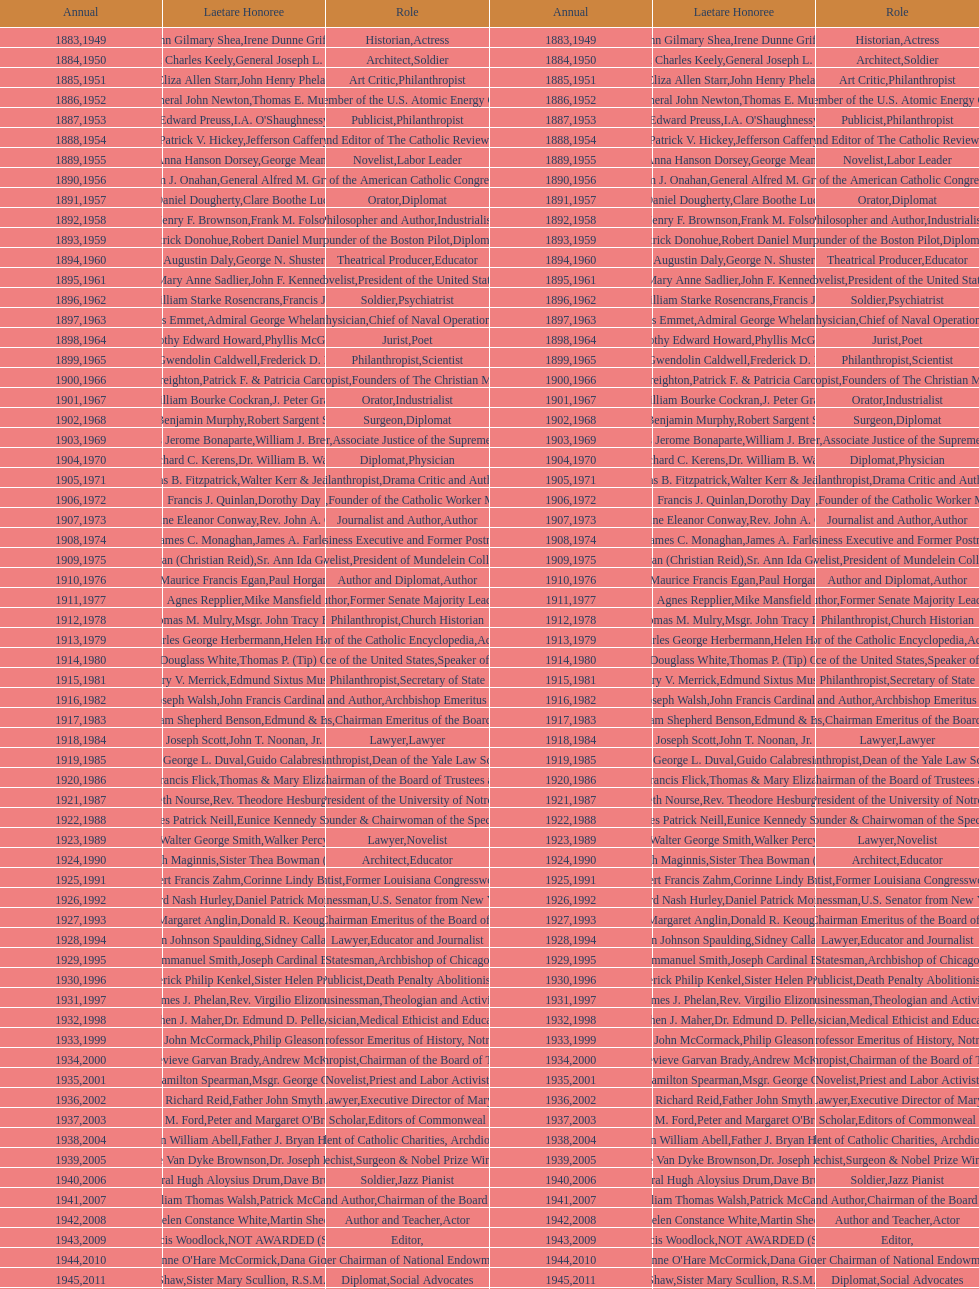How many are or were journalists? 5. Could you parse the entire table as a dict? {'header': ['Annual', 'Laetare Honoree', 'Role', 'Annual', 'Laetare Honoree', 'Role'], 'rows': [['1883', 'John Gilmary Shea', 'Historian', '1949', 'Irene Dunne Griffin', 'Actress'], ['1884', 'Patrick Charles Keely', 'Architect', '1950', 'General Joseph L. Collins', 'Soldier'], ['1885', 'Eliza Allen Starr', 'Art Critic', '1951', 'John Henry Phelan', 'Philanthropist'], ['1886', 'General John Newton', 'Engineer', '1952', 'Thomas E. Murray', 'Member of the U.S. Atomic Energy Commission'], ['1887', 'Edward Preuss', 'Publicist', '1953', "I.A. O'Shaughnessy", 'Philanthropist'], ['1888', 'Patrick V. Hickey', 'Founder and Editor of The Catholic Review', '1954', 'Jefferson Caffery', 'Diplomat'], ['1889', 'Anna Hanson Dorsey', 'Novelist', '1955', 'George Meany', 'Labor Leader'], ['1890', 'William J. Onahan', 'Organizer of the American Catholic Congress', '1956', 'General Alfred M. Gruenther', 'Soldier'], ['1891', 'Daniel Dougherty', 'Orator', '1957', 'Clare Boothe Luce', 'Diplomat'], ['1892', 'Henry F. Brownson', 'Philosopher and Author', '1958', 'Frank M. Folsom', 'Industrialist'], ['1893', 'Patrick Donohue', 'Founder of the Boston Pilot', '1959', 'Robert Daniel Murphy', 'Diplomat'], ['1894', 'Augustin Daly', 'Theatrical Producer', '1960', 'George N. Shuster', 'Educator'], ['1895', 'Mary Anne Sadlier', 'Novelist', '1961', 'John F. Kennedy', 'President of the United States'], ['1896', 'General William Starke Rosencrans', 'Soldier', '1962', 'Francis J. Braceland', 'Psychiatrist'], ['1897', 'Thomas Addis Emmet', 'Physician', '1963', 'Admiral George Whelan Anderson, Jr.', 'Chief of Naval Operations'], ['1898', 'Timothy Edward Howard', 'Jurist', '1964', 'Phyllis McGinley', 'Poet'], ['1899', 'Mary Gwendolin Caldwell', 'Philanthropist', '1965', 'Frederick D. Rossini', 'Scientist'], ['1900', 'John A. Creighton', 'Philanthropist', '1966', 'Patrick F. & Patricia Caron Crowley', 'Founders of The Christian Movement'], ['1901', 'William Bourke Cockran', 'Orator', '1967', 'J. Peter Grace', 'Industrialist'], ['1902', 'John Benjamin Murphy', 'Surgeon', '1968', 'Robert Sargent Shriver', 'Diplomat'], ['1903', 'Charles Jerome Bonaparte', 'Lawyer', '1969', 'William J. Brennan Jr.', 'Associate Justice of the Supreme Court'], ['1904', 'Richard C. Kerens', 'Diplomat', '1970', 'Dr. William B. Walsh', 'Physician'], ['1905', 'Thomas B. Fitzpatrick', 'Philanthropist', '1971', 'Walter Kerr & Jean Kerr', 'Drama Critic and Author'], ['1906', 'Francis J. Quinlan', 'Physician', '1972', 'Dorothy Day', 'Founder of the Catholic Worker Movement'], ['1907', 'Katherine Eleanor Conway', 'Journalist and Author', '1973', "Rev. John A. O'Brien", 'Author'], ['1908', 'James C. Monaghan', 'Economist', '1974', 'James A. Farley', 'Business Executive and Former Postmaster General'], ['1909', 'Frances Tieran (Christian Reid)', 'Novelist', '1975', 'Sr. Ann Ida Gannon, BMV', 'President of Mundelein College'], ['1910', 'Maurice Francis Egan', 'Author and Diplomat', '1976', 'Paul Horgan', 'Author'], ['1911', 'Agnes Repplier', 'Author', '1977', 'Mike Mansfield', 'Former Senate Majority Leader'], ['1912', 'Thomas M. Mulry', 'Philanthropist', '1978', 'Msgr. John Tracy Ellis', 'Church Historian'], ['1913', 'Charles George Herbermann', 'Editor of the Catholic Encyclopedia', '1979', 'Helen Hayes', 'Actress'], ['1914', 'Edward Douglass White', 'Chief Justice of the United States', '1980', "Thomas P. (Tip) O'Neill Jr.", 'Speaker of the House'], ['1915', 'Mary V. Merrick', 'Philanthropist', '1981', 'Edmund Sixtus Muskie', 'Secretary of State'], ['1916', 'James Joseph Walsh', 'Physician and Author', '1982', 'John Francis Cardinal Dearden', 'Archbishop Emeritus of Detroit'], ['1917', 'Admiral William Shepherd Benson', 'Chief of Naval Operations', '1983', 'Edmund & Evelyn Stephan', 'Chairman Emeritus of the Board of Trustees and his wife'], ['1918', 'Joseph Scott', 'Lawyer', '1984', 'John T. Noonan, Jr.', 'Lawyer'], ['1919', 'George L. Duval', 'Philanthropist', '1985', 'Guido Calabresi', 'Dean of the Yale Law School'], ['1920', 'Lawrence Francis Flick', 'Physician', '1986', 'Thomas & Mary Elizabeth Carney', 'Chairman of the Board of Trustees and his wife'], ['1921', 'Elizabeth Nourse', 'Artist', '1987', 'Rev. Theodore Hesburgh, CSC', 'President of the University of Notre Dame'], ['1922', 'Charles Patrick Neill', 'Economist', '1988', 'Eunice Kennedy Shriver', 'Founder & Chairwoman of the Special Olympics'], ['1923', 'Walter George Smith', 'Lawyer', '1989', 'Walker Percy', 'Novelist'], ['1924', 'Charles Donagh Maginnis', 'Architect', '1990', 'Sister Thea Bowman (posthumously)', 'Educator'], ['1925', 'Albert Francis Zahm', 'Scientist', '1991', 'Corinne Lindy Boggs', 'Former Louisiana Congresswoman'], ['1926', 'Edward Nash Hurley', 'Businessman', '1992', 'Daniel Patrick Moynihan', 'U.S. Senator from New York'], ['1927', 'Margaret Anglin', 'Actress', '1993', 'Donald R. Keough', 'Chairman Emeritus of the Board of Trustees'], ['1928', 'John Johnson Spaulding', 'Lawyer', '1994', 'Sidney Callahan', 'Educator and Journalist'], ['1929', 'Alfred Emmanuel Smith', 'Statesman', '1995', 'Joseph Cardinal Bernardin', 'Archbishop of Chicago'], ['1930', 'Frederick Philip Kenkel', 'Publicist', '1996', 'Sister Helen Prejean', 'Death Penalty Abolitionist'], ['1931', 'James J. Phelan', 'Businessman', '1997', 'Rev. Virgilio Elizondo', 'Theologian and Activist'], ['1932', 'Stephen J. Maher', 'Physician', '1998', 'Dr. Edmund D. Pellegrino', 'Medical Ethicist and Educator'], ['1933', 'John McCormack', 'Artist', '1999', 'Philip Gleason', 'Professor Emeritus of History, Notre Dame'], ['1934', 'Genevieve Garvan Brady', 'Philanthropist', '2000', 'Andrew McKenna', 'Chairman of the Board of Trustees'], ['1935', 'Francis Hamilton Spearman', 'Novelist', '2001', 'Msgr. George G. Higgins', 'Priest and Labor Activist'], ['1936', 'Richard Reid', 'Journalist and Lawyer', '2002', 'Father John Smyth', 'Executive Director of Maryville Academy'], ['1937', 'Jeremiah D. M. Ford', 'Scholar', '2003', "Peter and Margaret O'Brien Steinfels", 'Editors of Commonweal'], ['1938', 'Irvin William Abell', 'Surgeon', '2004', 'Father J. Bryan Hehir', 'President of Catholic Charities, Archdiocese of Boston'], ['1939', 'Josephine Van Dyke Brownson', 'Catechist', '2005', 'Dr. Joseph E. Murray', 'Surgeon & Nobel Prize Winner'], ['1940', 'General Hugh Aloysius Drum', 'Soldier', '2006', 'Dave Brubeck', 'Jazz Pianist'], ['1941', 'William Thomas Walsh', 'Journalist and Author', '2007', 'Patrick McCartan', 'Chairman of the Board of Trustees'], ['1942', 'Helen Constance White', 'Author and Teacher', '2008', 'Martin Sheen', 'Actor'], ['1943', 'Thomas Francis Woodlock', 'Editor', '2009', 'NOT AWARDED (SEE BELOW)', ''], ['1944', "Anne O'Hare McCormick", 'Journalist', '2010', 'Dana Gioia', 'Former Chairman of National Endowment for the Arts'], ['1945', 'Gardiner Howland Shaw', 'Diplomat', '2011', 'Sister Mary Scullion, R.S.M., & Joan McConnon', 'Social Advocates'], ['1946', 'Carlton J. H. Hayes', 'Historian and Diplomat', '2012', 'Ken Hackett', 'Former President of Catholic Relief Services'], ['1947', 'William G. Bruce', 'Publisher and Civic Leader', '2013', 'Sister Susanne Gallagher, S.P.\\nSister Mary Therese Harrington, S.H.\\nRev. James H. McCarthy', 'Founders of S.P.R.E.D. (Special Religious Education Development Network)'], ['1948', 'Frank C. Walker', 'Postmaster General and Civic Leader', '2014', 'Kenneth R. Miller', 'Professor of Biology at Brown University']]} 